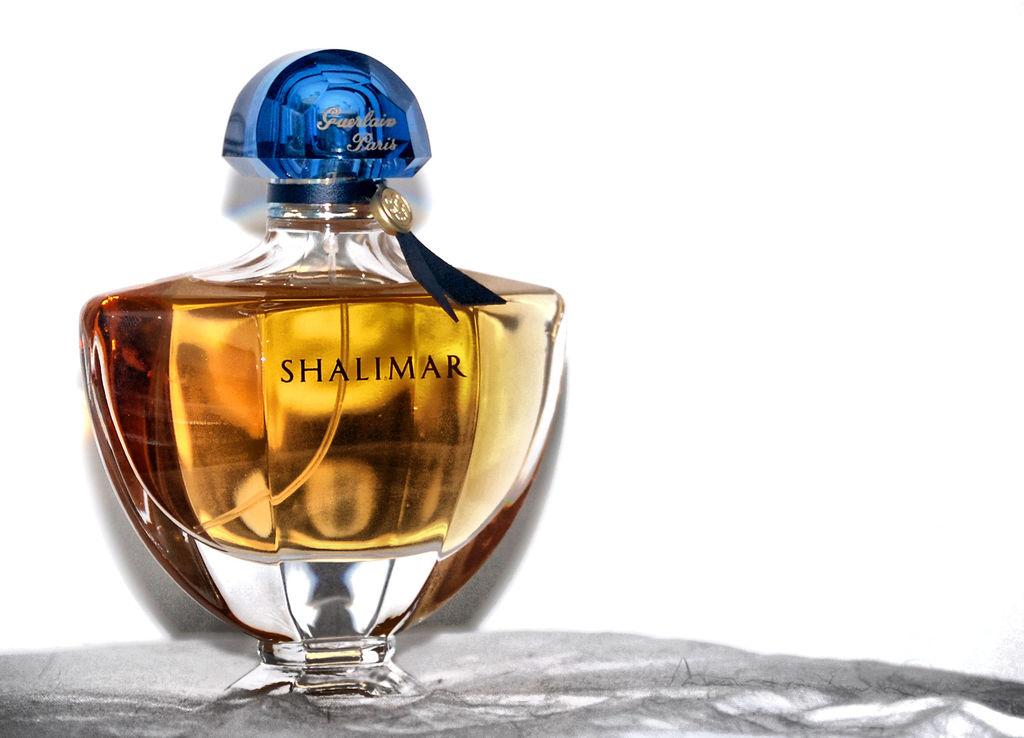<image>
Provide a brief description of the given image. A glass bottle with a blue top containing a perfume fragrance called Shalimar. 